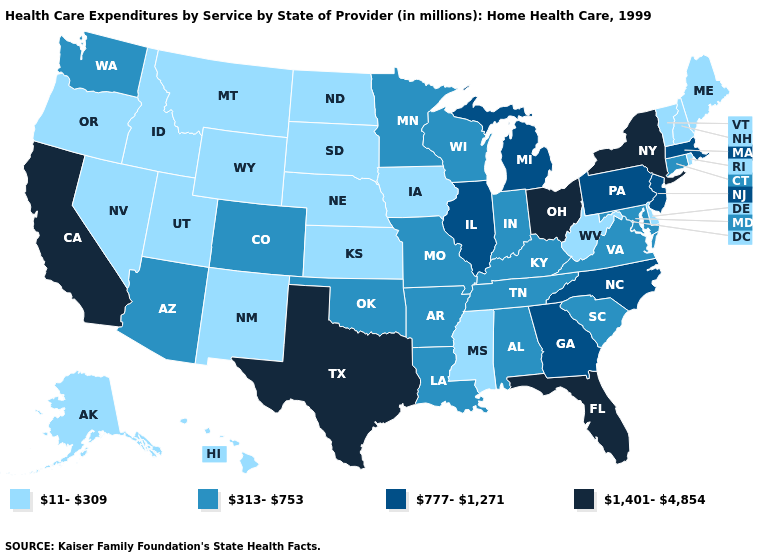Does Connecticut have the lowest value in the USA?
Keep it brief. No. What is the lowest value in the USA?
Short answer required. 11-309. Name the states that have a value in the range 313-753?
Be succinct. Alabama, Arizona, Arkansas, Colorado, Connecticut, Indiana, Kentucky, Louisiana, Maryland, Minnesota, Missouri, Oklahoma, South Carolina, Tennessee, Virginia, Washington, Wisconsin. Which states hav the highest value in the Northeast?
Keep it brief. New York. Does New Hampshire have a higher value than Maine?
Write a very short answer. No. What is the value of South Carolina?
Concise answer only. 313-753. Does Florida have the lowest value in the South?
Short answer required. No. Does Montana have the highest value in the USA?
Quick response, please. No. What is the value of California?
Concise answer only. 1,401-4,854. Does the first symbol in the legend represent the smallest category?
Concise answer only. Yes. What is the value of Kansas?
Give a very brief answer. 11-309. What is the lowest value in the USA?
Short answer required. 11-309. What is the value of Florida?
Concise answer only. 1,401-4,854. What is the lowest value in the USA?
Quick response, please. 11-309. What is the value of Wyoming?
Be succinct. 11-309. 